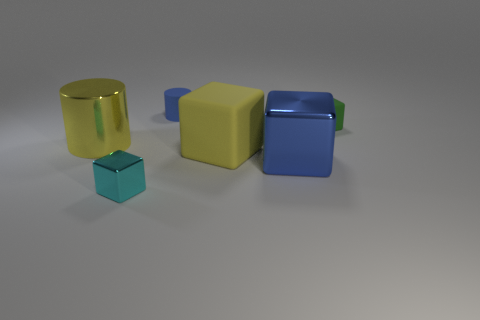Are there fewer big yellow rubber things to the right of the rubber cylinder than big shiny objects?
Provide a short and direct response. Yes. There is a rubber object that is the same color as the metal cylinder; what is its size?
Offer a terse response. Large. Does the yellow block have the same material as the cyan object?
Ensure brevity in your answer.  No. What number of things are either large yellow objects that are on the right side of the big yellow metal cylinder or small things that are to the left of the yellow rubber block?
Your response must be concise. 3. Are there any other yellow shiny things of the same size as the yellow metal thing?
Your answer should be very brief. No. What is the color of the other tiny thing that is the same shape as the small cyan metal thing?
Offer a very short reply. Green. There is a cylinder in front of the small rubber cube; are there any small blocks that are right of it?
Keep it short and to the point. Yes. There is a tiny matte thing in front of the blue rubber cylinder; is its shape the same as the cyan thing?
Your answer should be compact. Yes. The small green matte thing has what shape?
Offer a terse response. Cube. How many big blocks have the same material as the big blue object?
Make the answer very short. 0. 